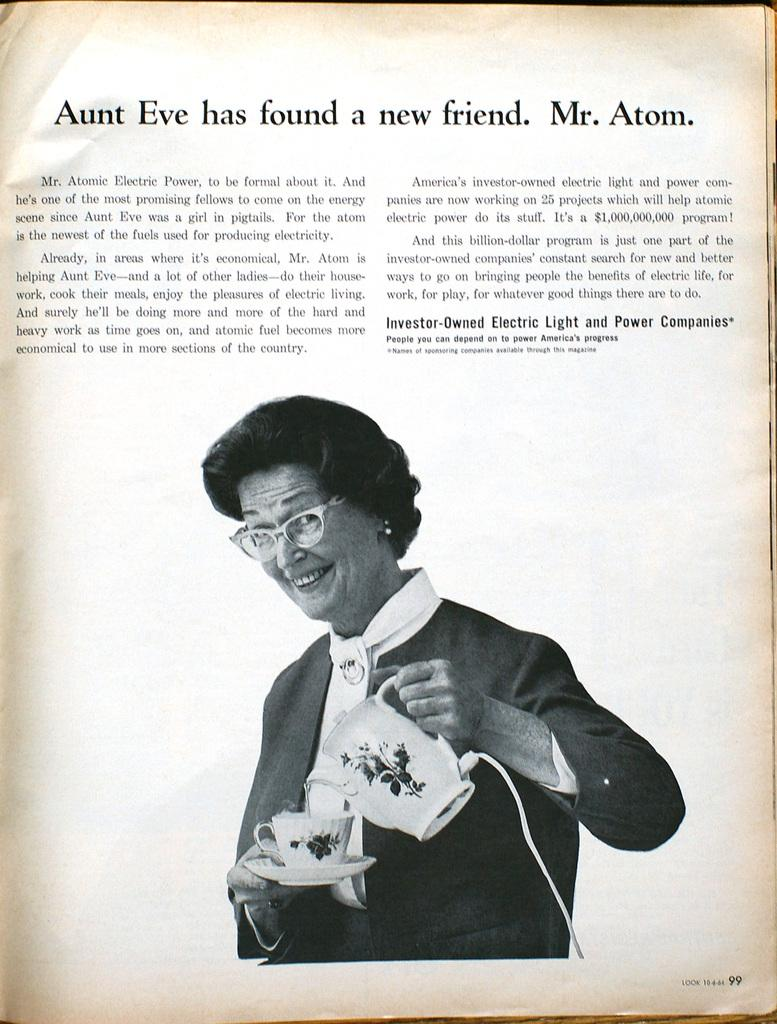Who is the main subject in the image? There is a woman in the image. What is the woman holding in the image? The woman is holding a tea kettle. What is written or depicted above the woman and tea kettle? There is text above the woman and tea kettle. How is the image presented? The image is a print. What type of land can be seen in the image? There is no land visible in the image, as it features a woman holding a tea kettle with text above her. What causes the woman to feel shame in the image? There is no indication of shame or any emotional state in the image; it simply shows a woman holding a tea kettle with text above her. 